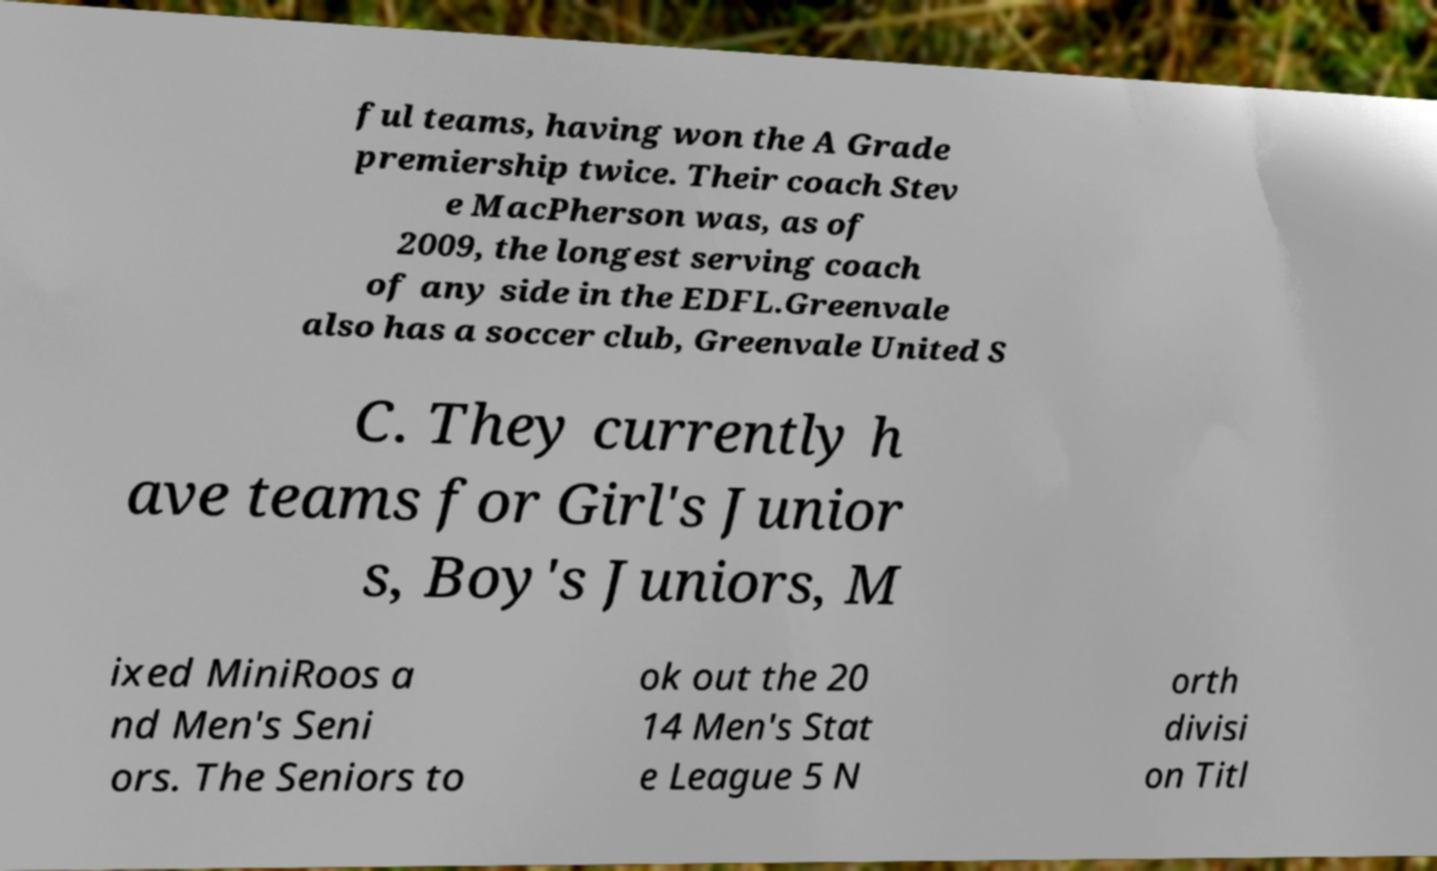For documentation purposes, I need the text within this image transcribed. Could you provide that? ful teams, having won the A Grade premiership twice. Their coach Stev e MacPherson was, as of 2009, the longest serving coach of any side in the EDFL.Greenvale also has a soccer club, Greenvale United S C. They currently h ave teams for Girl's Junior s, Boy's Juniors, M ixed MiniRoos a nd Men's Seni ors. The Seniors to ok out the 20 14 Men's Stat e League 5 N orth divisi on Titl 